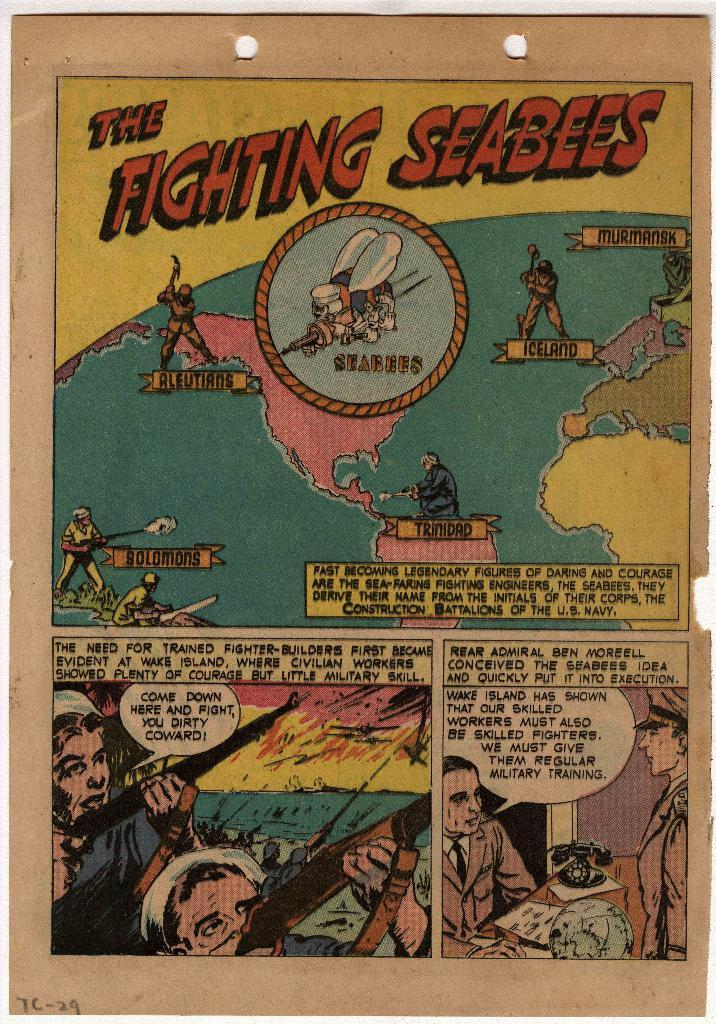<image>
Relay a brief, clear account of the picture shown. The Fighting Seabees comic features soldiers fighting in a battle. 